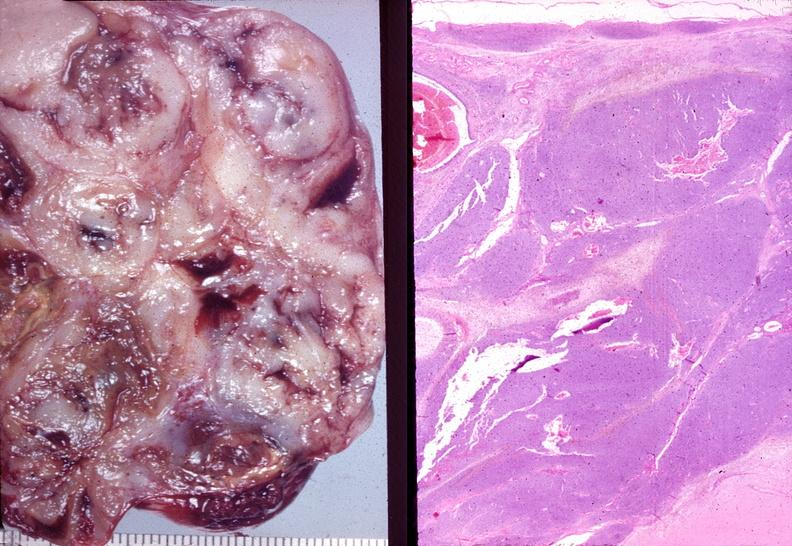s female reproductive present?
Answer the question using a single word or phrase. Yes 